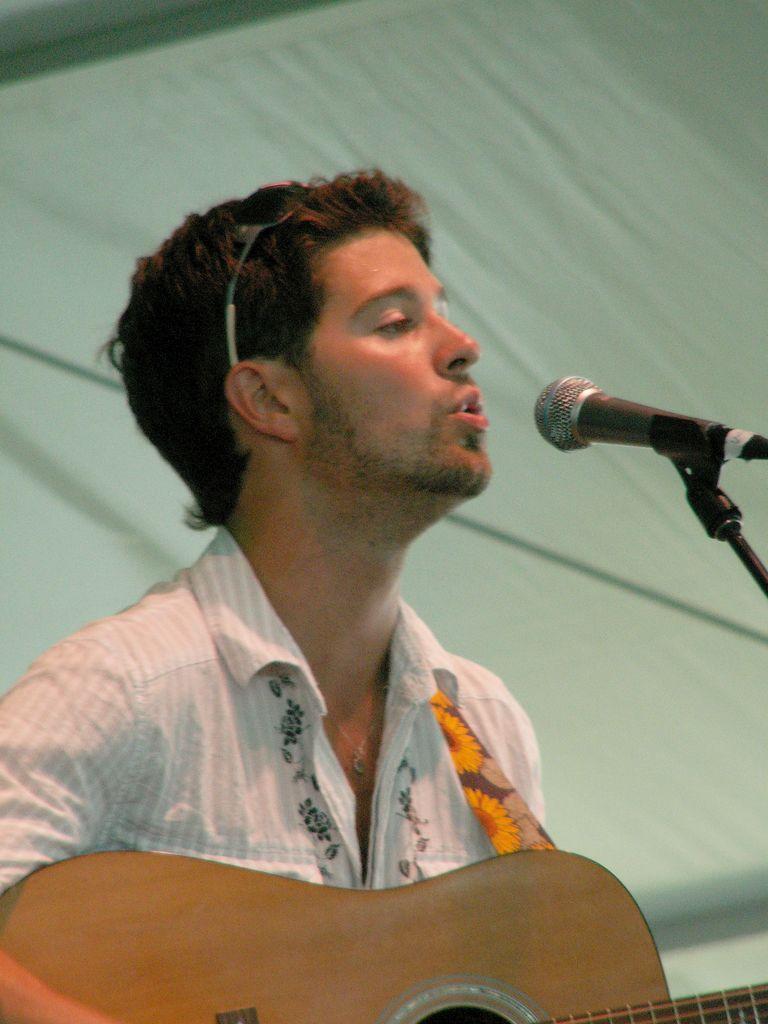Describe this image in one or two sentences. In the picture we can see a man talking in the microphone, a man is wearing a white shirt with the guitar. In the background we can find a white curtain. 